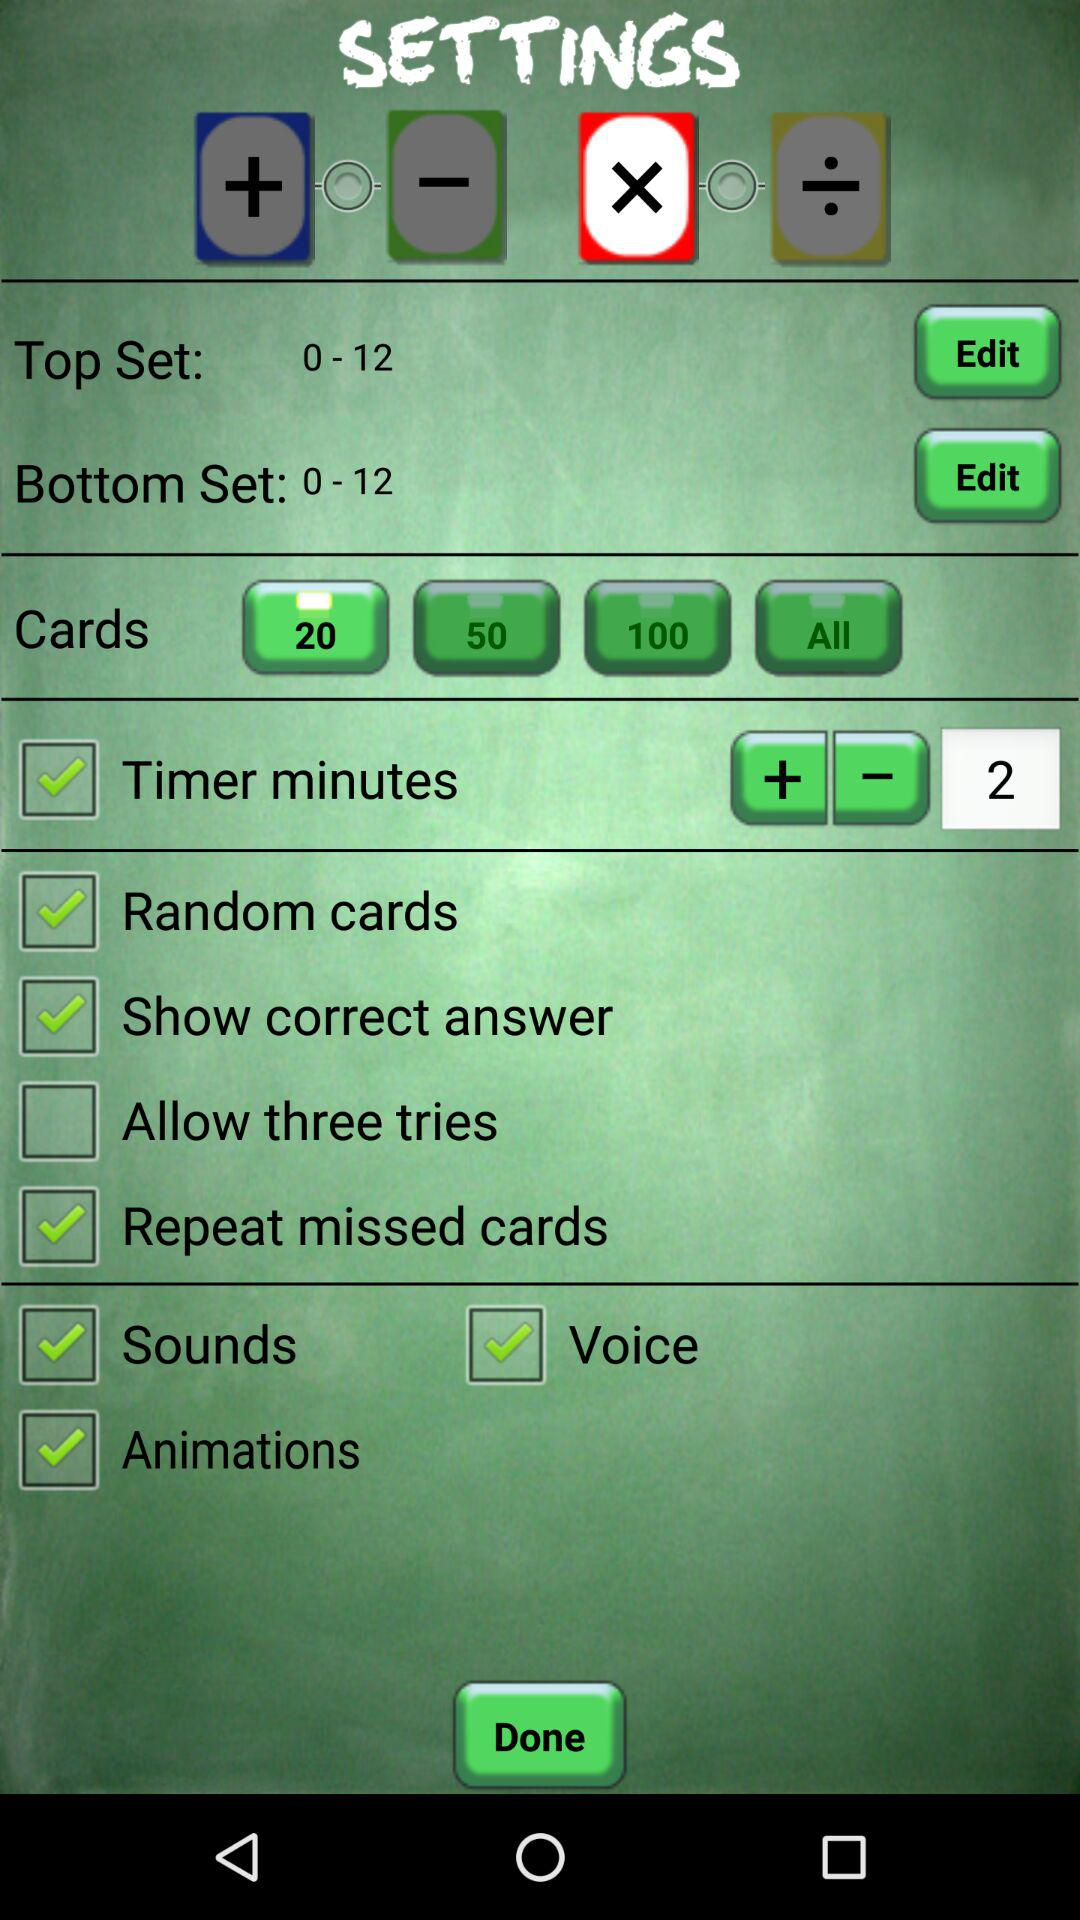What is the status of the "Random cards"? The status is on. 